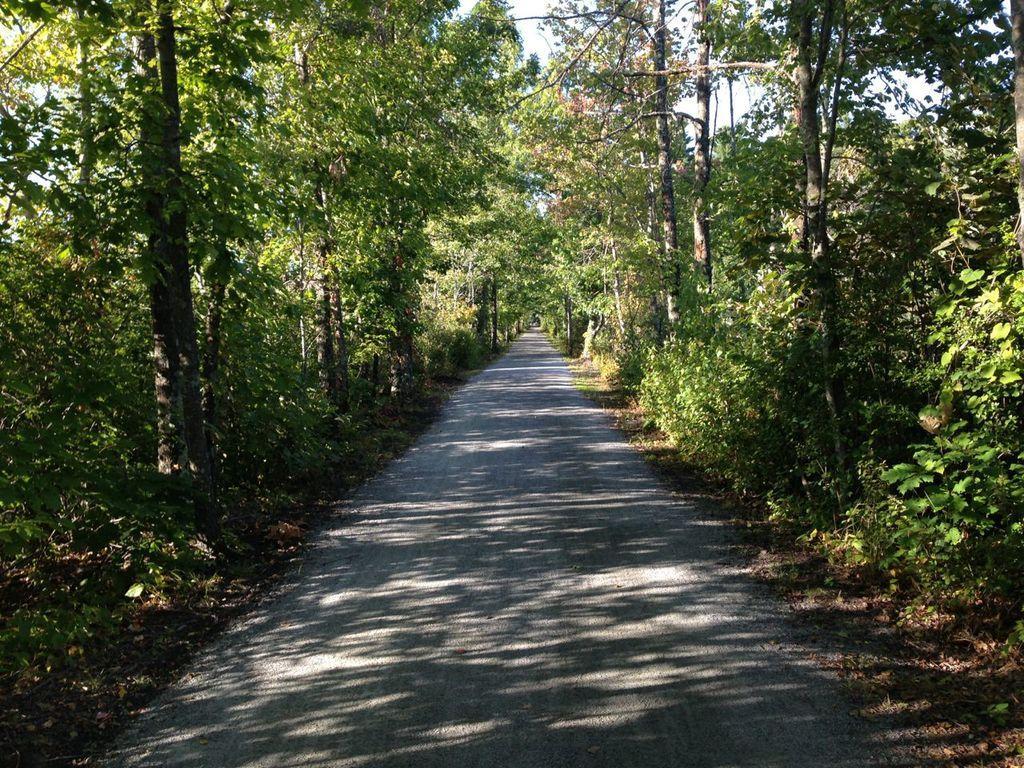Can you describe this image briefly? In this image I can see a road. On the left and right side, I can see the trees. 